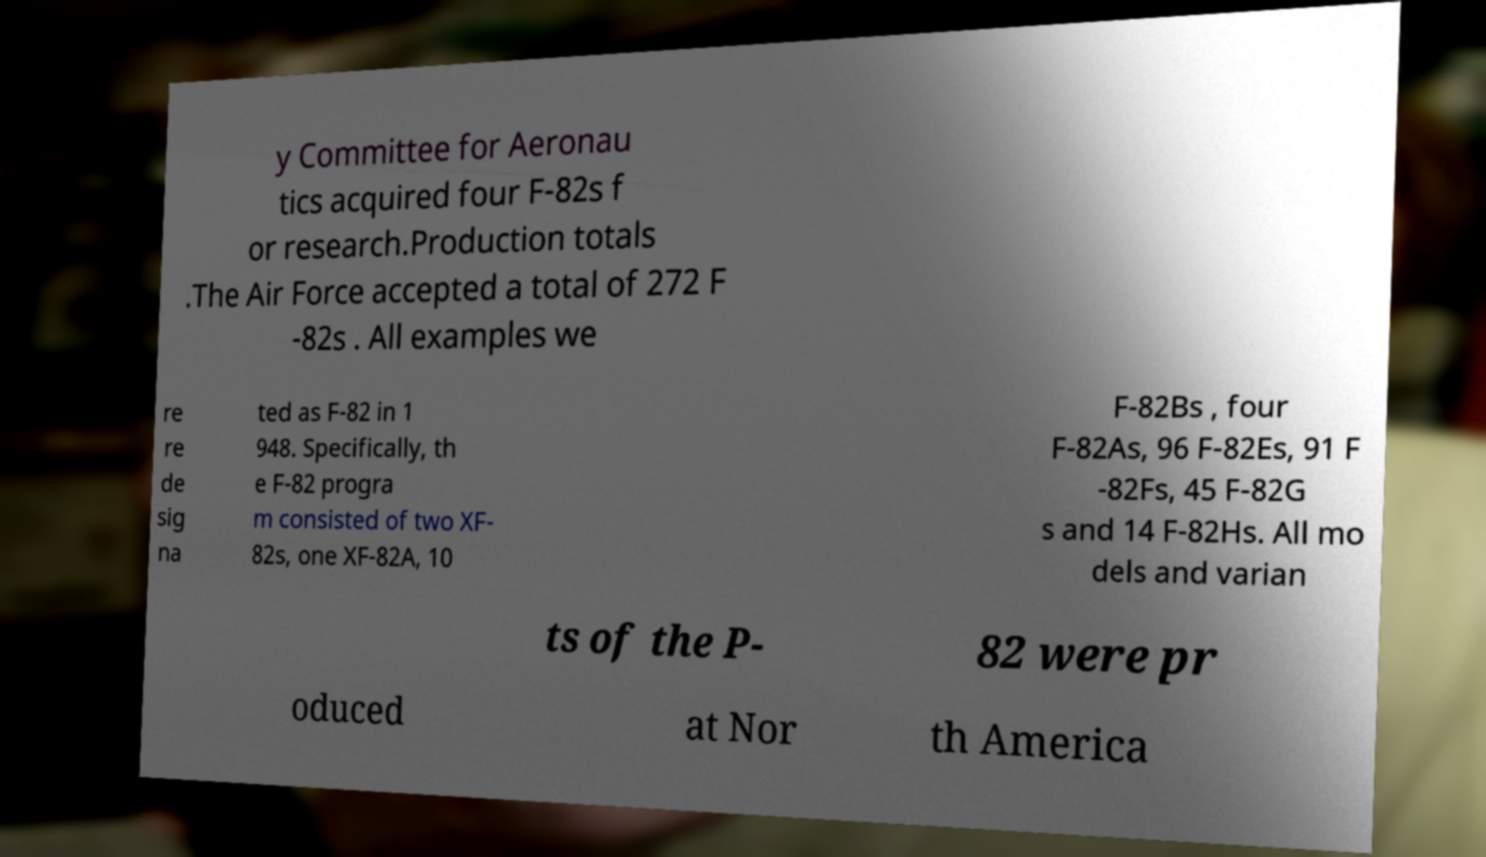I need the written content from this picture converted into text. Can you do that? y Committee for Aeronau tics acquired four F-82s f or research.Production totals .The Air Force accepted a total of 272 F -82s . All examples we re re de sig na ted as F-82 in 1 948. Specifically, th e F-82 progra m consisted of two XF- 82s, one XF-82A, 10 F-82Bs , four F-82As, 96 F-82Es, 91 F -82Fs, 45 F-82G s and 14 F-82Hs. All mo dels and varian ts of the P- 82 were pr oduced at Nor th America 